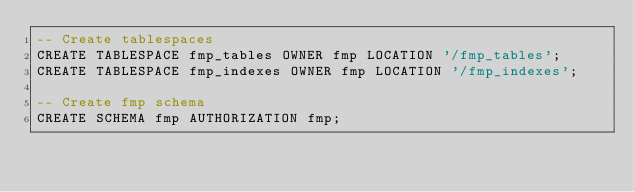Convert code to text. <code><loc_0><loc_0><loc_500><loc_500><_SQL_>-- Create tablespaces
CREATE TABLESPACE fmp_tables OWNER fmp LOCATION '/fmp_tables';
CREATE TABLESPACE fmp_indexes OWNER fmp LOCATION '/fmp_indexes';

-- Create fmp schema
CREATE SCHEMA fmp AUTHORIZATION fmp;
</code> 